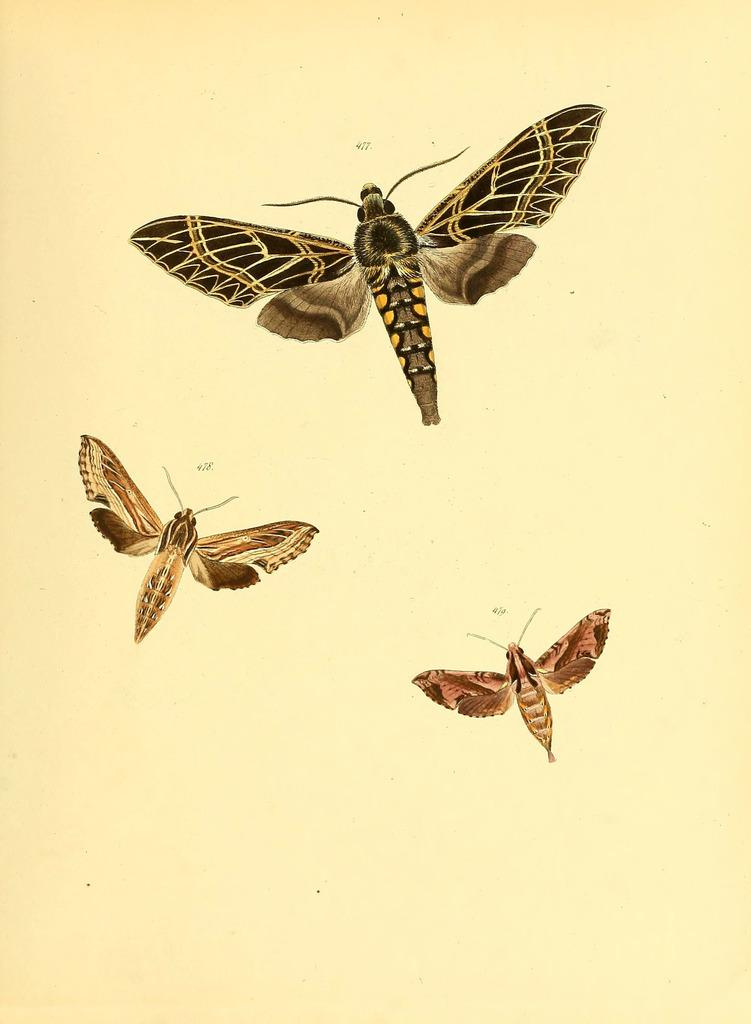How many insects are present in the image? There are three insects in the picture. Can you describe the insects in terms of their sizes? The insects are of different sizes. What type of advertisement can be seen on the swing in the image? There is no swing or advertisement present in the image; it features three insects of different sizes. 